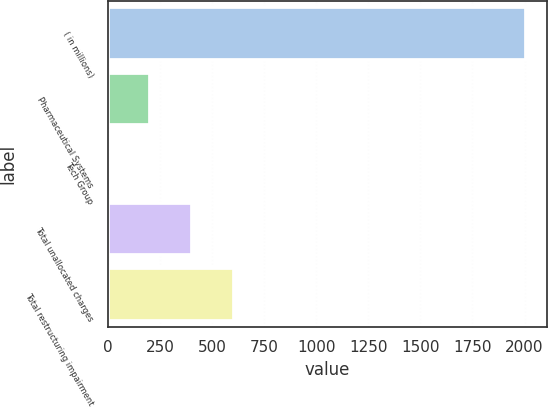Convert chart to OTSL. <chart><loc_0><loc_0><loc_500><loc_500><bar_chart><fcel>( in millions)<fcel>Pharmaceutical Systems<fcel>Tech Group<fcel>Total unallocated charges<fcel>Total restructuring impairment<nl><fcel>2007<fcel>200.88<fcel>0.2<fcel>401.56<fcel>602.24<nl></chart> 